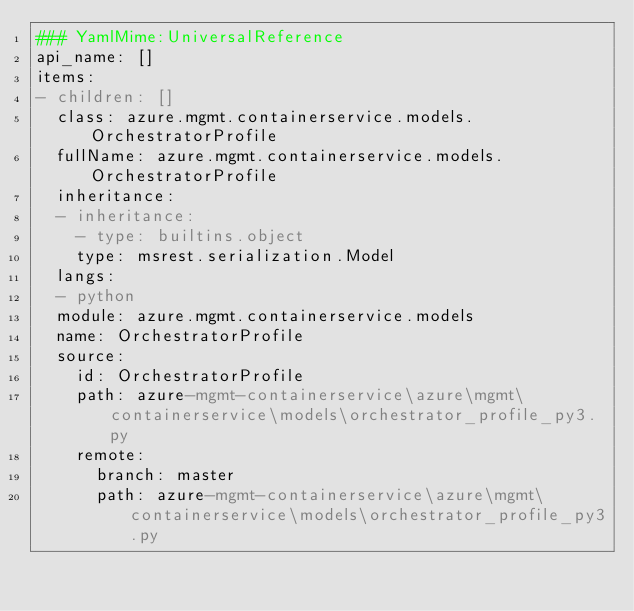<code> <loc_0><loc_0><loc_500><loc_500><_YAML_>### YamlMime:UniversalReference
api_name: []
items:
- children: []
  class: azure.mgmt.containerservice.models.OrchestratorProfile
  fullName: azure.mgmt.containerservice.models.OrchestratorProfile
  inheritance:
  - inheritance:
    - type: builtins.object
    type: msrest.serialization.Model
  langs:
  - python
  module: azure.mgmt.containerservice.models
  name: OrchestratorProfile
  source:
    id: OrchestratorProfile
    path: azure-mgmt-containerservice\azure\mgmt\containerservice\models\orchestrator_profile_py3.py
    remote:
      branch: master
      path: azure-mgmt-containerservice\azure\mgmt\containerservice\models\orchestrator_profile_py3.py</code> 